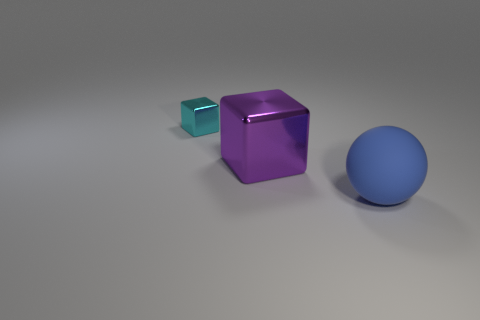Add 2 large cyan metal spheres. How many objects exist? 5 Subtract 0 gray cylinders. How many objects are left? 3 Subtract all balls. How many objects are left? 2 Subtract 1 balls. How many balls are left? 0 Subtract all cyan blocks. Subtract all gray cylinders. How many blocks are left? 1 Subtract all brown balls. How many red cubes are left? 0 Subtract all large metallic blocks. Subtract all tiny cyan shiny objects. How many objects are left? 1 Add 2 big blocks. How many big blocks are left? 3 Add 1 cyan metal things. How many cyan metal things exist? 2 